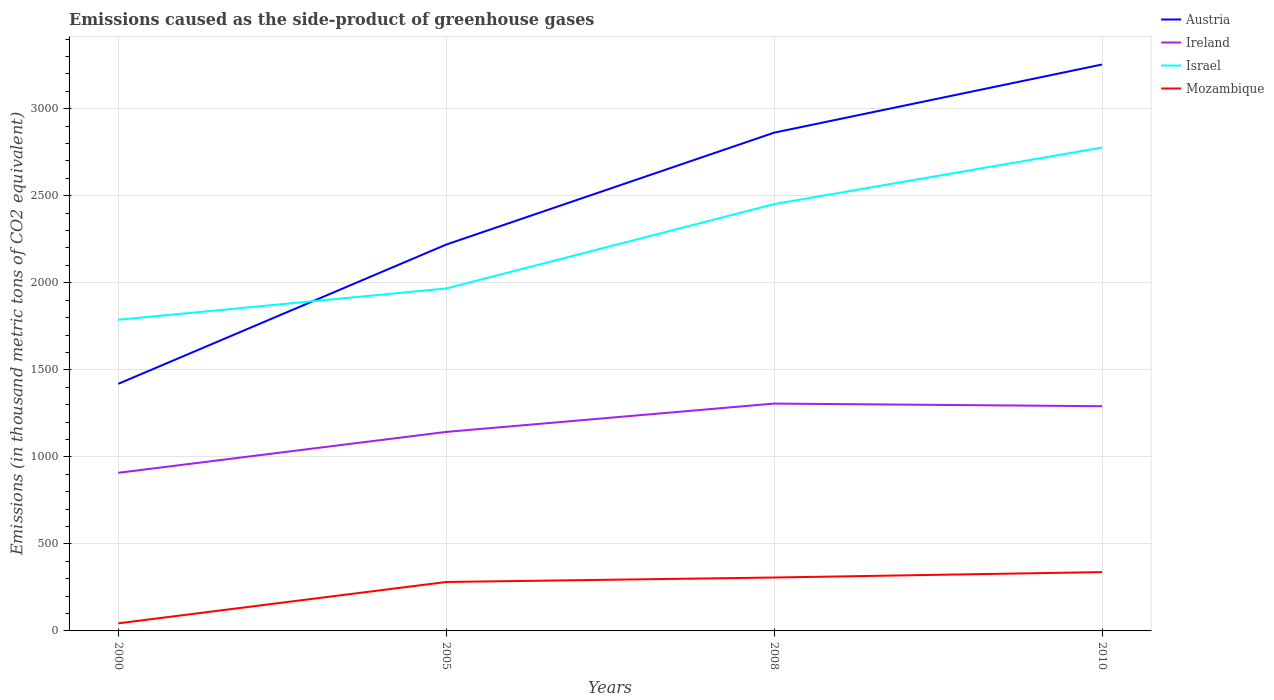How many different coloured lines are there?
Provide a short and direct response. 4. Is the number of lines equal to the number of legend labels?
Your answer should be very brief. Yes. Across all years, what is the maximum emissions caused as the side-product of greenhouse gases in Israel?
Provide a short and direct response. 1787.6. What is the total emissions caused as the side-product of greenhouse gases in Israel in the graph?
Your answer should be compact. -664.5. What is the difference between the highest and the second highest emissions caused as the side-product of greenhouse gases in Mozambique?
Your response must be concise. 294.3. What is the difference between the highest and the lowest emissions caused as the side-product of greenhouse gases in Israel?
Your response must be concise. 2. How many years are there in the graph?
Make the answer very short. 4. Are the values on the major ticks of Y-axis written in scientific E-notation?
Your answer should be compact. No. Does the graph contain grids?
Ensure brevity in your answer.  Yes. What is the title of the graph?
Your answer should be compact. Emissions caused as the side-product of greenhouse gases. What is the label or title of the Y-axis?
Provide a succinct answer. Emissions (in thousand metric tons of CO2 equivalent). What is the Emissions (in thousand metric tons of CO2 equivalent) in Austria in 2000?
Your answer should be very brief. 1419.5. What is the Emissions (in thousand metric tons of CO2 equivalent) in Ireland in 2000?
Ensure brevity in your answer.  908.4. What is the Emissions (in thousand metric tons of CO2 equivalent) in Israel in 2000?
Offer a terse response. 1787.6. What is the Emissions (in thousand metric tons of CO2 equivalent) of Mozambique in 2000?
Give a very brief answer. 43.7. What is the Emissions (in thousand metric tons of CO2 equivalent) of Austria in 2005?
Make the answer very short. 2219.5. What is the Emissions (in thousand metric tons of CO2 equivalent) in Ireland in 2005?
Ensure brevity in your answer.  1143.3. What is the Emissions (in thousand metric tons of CO2 equivalent) of Israel in 2005?
Your answer should be very brief. 1967.4. What is the Emissions (in thousand metric tons of CO2 equivalent) of Mozambique in 2005?
Your response must be concise. 281.1. What is the Emissions (in thousand metric tons of CO2 equivalent) of Austria in 2008?
Provide a succinct answer. 2862.4. What is the Emissions (in thousand metric tons of CO2 equivalent) in Ireland in 2008?
Keep it short and to the point. 1306.1. What is the Emissions (in thousand metric tons of CO2 equivalent) of Israel in 2008?
Your answer should be very brief. 2452.1. What is the Emissions (in thousand metric tons of CO2 equivalent) of Mozambique in 2008?
Offer a terse response. 306.8. What is the Emissions (in thousand metric tons of CO2 equivalent) of Austria in 2010?
Provide a short and direct response. 3254. What is the Emissions (in thousand metric tons of CO2 equivalent) of Ireland in 2010?
Make the answer very short. 1291. What is the Emissions (in thousand metric tons of CO2 equivalent) in Israel in 2010?
Your answer should be compact. 2777. What is the Emissions (in thousand metric tons of CO2 equivalent) in Mozambique in 2010?
Offer a terse response. 338. Across all years, what is the maximum Emissions (in thousand metric tons of CO2 equivalent) of Austria?
Give a very brief answer. 3254. Across all years, what is the maximum Emissions (in thousand metric tons of CO2 equivalent) of Ireland?
Offer a very short reply. 1306.1. Across all years, what is the maximum Emissions (in thousand metric tons of CO2 equivalent) of Israel?
Ensure brevity in your answer.  2777. Across all years, what is the maximum Emissions (in thousand metric tons of CO2 equivalent) of Mozambique?
Keep it short and to the point. 338. Across all years, what is the minimum Emissions (in thousand metric tons of CO2 equivalent) in Austria?
Your response must be concise. 1419.5. Across all years, what is the minimum Emissions (in thousand metric tons of CO2 equivalent) in Ireland?
Offer a very short reply. 908.4. Across all years, what is the minimum Emissions (in thousand metric tons of CO2 equivalent) in Israel?
Offer a terse response. 1787.6. Across all years, what is the minimum Emissions (in thousand metric tons of CO2 equivalent) in Mozambique?
Give a very brief answer. 43.7. What is the total Emissions (in thousand metric tons of CO2 equivalent) of Austria in the graph?
Make the answer very short. 9755.4. What is the total Emissions (in thousand metric tons of CO2 equivalent) in Ireland in the graph?
Give a very brief answer. 4648.8. What is the total Emissions (in thousand metric tons of CO2 equivalent) of Israel in the graph?
Give a very brief answer. 8984.1. What is the total Emissions (in thousand metric tons of CO2 equivalent) of Mozambique in the graph?
Provide a short and direct response. 969.6. What is the difference between the Emissions (in thousand metric tons of CO2 equivalent) in Austria in 2000 and that in 2005?
Provide a short and direct response. -800. What is the difference between the Emissions (in thousand metric tons of CO2 equivalent) in Ireland in 2000 and that in 2005?
Offer a terse response. -234.9. What is the difference between the Emissions (in thousand metric tons of CO2 equivalent) in Israel in 2000 and that in 2005?
Keep it short and to the point. -179.8. What is the difference between the Emissions (in thousand metric tons of CO2 equivalent) of Mozambique in 2000 and that in 2005?
Provide a succinct answer. -237.4. What is the difference between the Emissions (in thousand metric tons of CO2 equivalent) of Austria in 2000 and that in 2008?
Offer a very short reply. -1442.9. What is the difference between the Emissions (in thousand metric tons of CO2 equivalent) in Ireland in 2000 and that in 2008?
Make the answer very short. -397.7. What is the difference between the Emissions (in thousand metric tons of CO2 equivalent) of Israel in 2000 and that in 2008?
Ensure brevity in your answer.  -664.5. What is the difference between the Emissions (in thousand metric tons of CO2 equivalent) in Mozambique in 2000 and that in 2008?
Your response must be concise. -263.1. What is the difference between the Emissions (in thousand metric tons of CO2 equivalent) in Austria in 2000 and that in 2010?
Provide a short and direct response. -1834.5. What is the difference between the Emissions (in thousand metric tons of CO2 equivalent) of Ireland in 2000 and that in 2010?
Your response must be concise. -382.6. What is the difference between the Emissions (in thousand metric tons of CO2 equivalent) in Israel in 2000 and that in 2010?
Offer a very short reply. -989.4. What is the difference between the Emissions (in thousand metric tons of CO2 equivalent) in Mozambique in 2000 and that in 2010?
Give a very brief answer. -294.3. What is the difference between the Emissions (in thousand metric tons of CO2 equivalent) in Austria in 2005 and that in 2008?
Your response must be concise. -642.9. What is the difference between the Emissions (in thousand metric tons of CO2 equivalent) of Ireland in 2005 and that in 2008?
Make the answer very short. -162.8. What is the difference between the Emissions (in thousand metric tons of CO2 equivalent) in Israel in 2005 and that in 2008?
Provide a succinct answer. -484.7. What is the difference between the Emissions (in thousand metric tons of CO2 equivalent) of Mozambique in 2005 and that in 2008?
Make the answer very short. -25.7. What is the difference between the Emissions (in thousand metric tons of CO2 equivalent) of Austria in 2005 and that in 2010?
Give a very brief answer. -1034.5. What is the difference between the Emissions (in thousand metric tons of CO2 equivalent) of Ireland in 2005 and that in 2010?
Make the answer very short. -147.7. What is the difference between the Emissions (in thousand metric tons of CO2 equivalent) in Israel in 2005 and that in 2010?
Your answer should be very brief. -809.6. What is the difference between the Emissions (in thousand metric tons of CO2 equivalent) of Mozambique in 2005 and that in 2010?
Your response must be concise. -56.9. What is the difference between the Emissions (in thousand metric tons of CO2 equivalent) of Austria in 2008 and that in 2010?
Provide a succinct answer. -391.6. What is the difference between the Emissions (in thousand metric tons of CO2 equivalent) of Ireland in 2008 and that in 2010?
Your response must be concise. 15.1. What is the difference between the Emissions (in thousand metric tons of CO2 equivalent) in Israel in 2008 and that in 2010?
Ensure brevity in your answer.  -324.9. What is the difference between the Emissions (in thousand metric tons of CO2 equivalent) in Mozambique in 2008 and that in 2010?
Offer a terse response. -31.2. What is the difference between the Emissions (in thousand metric tons of CO2 equivalent) of Austria in 2000 and the Emissions (in thousand metric tons of CO2 equivalent) of Ireland in 2005?
Offer a very short reply. 276.2. What is the difference between the Emissions (in thousand metric tons of CO2 equivalent) in Austria in 2000 and the Emissions (in thousand metric tons of CO2 equivalent) in Israel in 2005?
Provide a succinct answer. -547.9. What is the difference between the Emissions (in thousand metric tons of CO2 equivalent) of Austria in 2000 and the Emissions (in thousand metric tons of CO2 equivalent) of Mozambique in 2005?
Offer a very short reply. 1138.4. What is the difference between the Emissions (in thousand metric tons of CO2 equivalent) in Ireland in 2000 and the Emissions (in thousand metric tons of CO2 equivalent) in Israel in 2005?
Give a very brief answer. -1059. What is the difference between the Emissions (in thousand metric tons of CO2 equivalent) in Ireland in 2000 and the Emissions (in thousand metric tons of CO2 equivalent) in Mozambique in 2005?
Your answer should be compact. 627.3. What is the difference between the Emissions (in thousand metric tons of CO2 equivalent) in Israel in 2000 and the Emissions (in thousand metric tons of CO2 equivalent) in Mozambique in 2005?
Keep it short and to the point. 1506.5. What is the difference between the Emissions (in thousand metric tons of CO2 equivalent) of Austria in 2000 and the Emissions (in thousand metric tons of CO2 equivalent) of Ireland in 2008?
Offer a very short reply. 113.4. What is the difference between the Emissions (in thousand metric tons of CO2 equivalent) of Austria in 2000 and the Emissions (in thousand metric tons of CO2 equivalent) of Israel in 2008?
Your answer should be compact. -1032.6. What is the difference between the Emissions (in thousand metric tons of CO2 equivalent) of Austria in 2000 and the Emissions (in thousand metric tons of CO2 equivalent) of Mozambique in 2008?
Ensure brevity in your answer.  1112.7. What is the difference between the Emissions (in thousand metric tons of CO2 equivalent) in Ireland in 2000 and the Emissions (in thousand metric tons of CO2 equivalent) in Israel in 2008?
Provide a short and direct response. -1543.7. What is the difference between the Emissions (in thousand metric tons of CO2 equivalent) of Ireland in 2000 and the Emissions (in thousand metric tons of CO2 equivalent) of Mozambique in 2008?
Provide a short and direct response. 601.6. What is the difference between the Emissions (in thousand metric tons of CO2 equivalent) in Israel in 2000 and the Emissions (in thousand metric tons of CO2 equivalent) in Mozambique in 2008?
Offer a very short reply. 1480.8. What is the difference between the Emissions (in thousand metric tons of CO2 equivalent) of Austria in 2000 and the Emissions (in thousand metric tons of CO2 equivalent) of Ireland in 2010?
Make the answer very short. 128.5. What is the difference between the Emissions (in thousand metric tons of CO2 equivalent) of Austria in 2000 and the Emissions (in thousand metric tons of CO2 equivalent) of Israel in 2010?
Your answer should be very brief. -1357.5. What is the difference between the Emissions (in thousand metric tons of CO2 equivalent) of Austria in 2000 and the Emissions (in thousand metric tons of CO2 equivalent) of Mozambique in 2010?
Your answer should be compact. 1081.5. What is the difference between the Emissions (in thousand metric tons of CO2 equivalent) of Ireland in 2000 and the Emissions (in thousand metric tons of CO2 equivalent) of Israel in 2010?
Provide a succinct answer. -1868.6. What is the difference between the Emissions (in thousand metric tons of CO2 equivalent) in Ireland in 2000 and the Emissions (in thousand metric tons of CO2 equivalent) in Mozambique in 2010?
Offer a terse response. 570.4. What is the difference between the Emissions (in thousand metric tons of CO2 equivalent) in Israel in 2000 and the Emissions (in thousand metric tons of CO2 equivalent) in Mozambique in 2010?
Offer a very short reply. 1449.6. What is the difference between the Emissions (in thousand metric tons of CO2 equivalent) of Austria in 2005 and the Emissions (in thousand metric tons of CO2 equivalent) of Ireland in 2008?
Provide a short and direct response. 913.4. What is the difference between the Emissions (in thousand metric tons of CO2 equivalent) of Austria in 2005 and the Emissions (in thousand metric tons of CO2 equivalent) of Israel in 2008?
Provide a succinct answer. -232.6. What is the difference between the Emissions (in thousand metric tons of CO2 equivalent) in Austria in 2005 and the Emissions (in thousand metric tons of CO2 equivalent) in Mozambique in 2008?
Your answer should be very brief. 1912.7. What is the difference between the Emissions (in thousand metric tons of CO2 equivalent) in Ireland in 2005 and the Emissions (in thousand metric tons of CO2 equivalent) in Israel in 2008?
Provide a short and direct response. -1308.8. What is the difference between the Emissions (in thousand metric tons of CO2 equivalent) in Ireland in 2005 and the Emissions (in thousand metric tons of CO2 equivalent) in Mozambique in 2008?
Make the answer very short. 836.5. What is the difference between the Emissions (in thousand metric tons of CO2 equivalent) of Israel in 2005 and the Emissions (in thousand metric tons of CO2 equivalent) of Mozambique in 2008?
Offer a very short reply. 1660.6. What is the difference between the Emissions (in thousand metric tons of CO2 equivalent) of Austria in 2005 and the Emissions (in thousand metric tons of CO2 equivalent) of Ireland in 2010?
Offer a terse response. 928.5. What is the difference between the Emissions (in thousand metric tons of CO2 equivalent) in Austria in 2005 and the Emissions (in thousand metric tons of CO2 equivalent) in Israel in 2010?
Give a very brief answer. -557.5. What is the difference between the Emissions (in thousand metric tons of CO2 equivalent) of Austria in 2005 and the Emissions (in thousand metric tons of CO2 equivalent) of Mozambique in 2010?
Give a very brief answer. 1881.5. What is the difference between the Emissions (in thousand metric tons of CO2 equivalent) of Ireland in 2005 and the Emissions (in thousand metric tons of CO2 equivalent) of Israel in 2010?
Your response must be concise. -1633.7. What is the difference between the Emissions (in thousand metric tons of CO2 equivalent) in Ireland in 2005 and the Emissions (in thousand metric tons of CO2 equivalent) in Mozambique in 2010?
Your answer should be compact. 805.3. What is the difference between the Emissions (in thousand metric tons of CO2 equivalent) in Israel in 2005 and the Emissions (in thousand metric tons of CO2 equivalent) in Mozambique in 2010?
Provide a succinct answer. 1629.4. What is the difference between the Emissions (in thousand metric tons of CO2 equivalent) of Austria in 2008 and the Emissions (in thousand metric tons of CO2 equivalent) of Ireland in 2010?
Make the answer very short. 1571.4. What is the difference between the Emissions (in thousand metric tons of CO2 equivalent) in Austria in 2008 and the Emissions (in thousand metric tons of CO2 equivalent) in Israel in 2010?
Your response must be concise. 85.4. What is the difference between the Emissions (in thousand metric tons of CO2 equivalent) of Austria in 2008 and the Emissions (in thousand metric tons of CO2 equivalent) of Mozambique in 2010?
Provide a short and direct response. 2524.4. What is the difference between the Emissions (in thousand metric tons of CO2 equivalent) of Ireland in 2008 and the Emissions (in thousand metric tons of CO2 equivalent) of Israel in 2010?
Provide a succinct answer. -1470.9. What is the difference between the Emissions (in thousand metric tons of CO2 equivalent) of Ireland in 2008 and the Emissions (in thousand metric tons of CO2 equivalent) of Mozambique in 2010?
Keep it short and to the point. 968.1. What is the difference between the Emissions (in thousand metric tons of CO2 equivalent) of Israel in 2008 and the Emissions (in thousand metric tons of CO2 equivalent) of Mozambique in 2010?
Ensure brevity in your answer.  2114.1. What is the average Emissions (in thousand metric tons of CO2 equivalent) of Austria per year?
Your answer should be very brief. 2438.85. What is the average Emissions (in thousand metric tons of CO2 equivalent) of Ireland per year?
Provide a succinct answer. 1162.2. What is the average Emissions (in thousand metric tons of CO2 equivalent) of Israel per year?
Ensure brevity in your answer.  2246.03. What is the average Emissions (in thousand metric tons of CO2 equivalent) of Mozambique per year?
Offer a terse response. 242.4. In the year 2000, what is the difference between the Emissions (in thousand metric tons of CO2 equivalent) of Austria and Emissions (in thousand metric tons of CO2 equivalent) of Ireland?
Your response must be concise. 511.1. In the year 2000, what is the difference between the Emissions (in thousand metric tons of CO2 equivalent) of Austria and Emissions (in thousand metric tons of CO2 equivalent) of Israel?
Provide a succinct answer. -368.1. In the year 2000, what is the difference between the Emissions (in thousand metric tons of CO2 equivalent) in Austria and Emissions (in thousand metric tons of CO2 equivalent) in Mozambique?
Keep it short and to the point. 1375.8. In the year 2000, what is the difference between the Emissions (in thousand metric tons of CO2 equivalent) of Ireland and Emissions (in thousand metric tons of CO2 equivalent) of Israel?
Your answer should be very brief. -879.2. In the year 2000, what is the difference between the Emissions (in thousand metric tons of CO2 equivalent) of Ireland and Emissions (in thousand metric tons of CO2 equivalent) of Mozambique?
Ensure brevity in your answer.  864.7. In the year 2000, what is the difference between the Emissions (in thousand metric tons of CO2 equivalent) of Israel and Emissions (in thousand metric tons of CO2 equivalent) of Mozambique?
Your answer should be compact. 1743.9. In the year 2005, what is the difference between the Emissions (in thousand metric tons of CO2 equivalent) of Austria and Emissions (in thousand metric tons of CO2 equivalent) of Ireland?
Make the answer very short. 1076.2. In the year 2005, what is the difference between the Emissions (in thousand metric tons of CO2 equivalent) in Austria and Emissions (in thousand metric tons of CO2 equivalent) in Israel?
Provide a succinct answer. 252.1. In the year 2005, what is the difference between the Emissions (in thousand metric tons of CO2 equivalent) of Austria and Emissions (in thousand metric tons of CO2 equivalent) of Mozambique?
Your answer should be compact. 1938.4. In the year 2005, what is the difference between the Emissions (in thousand metric tons of CO2 equivalent) in Ireland and Emissions (in thousand metric tons of CO2 equivalent) in Israel?
Keep it short and to the point. -824.1. In the year 2005, what is the difference between the Emissions (in thousand metric tons of CO2 equivalent) in Ireland and Emissions (in thousand metric tons of CO2 equivalent) in Mozambique?
Offer a terse response. 862.2. In the year 2005, what is the difference between the Emissions (in thousand metric tons of CO2 equivalent) in Israel and Emissions (in thousand metric tons of CO2 equivalent) in Mozambique?
Your answer should be compact. 1686.3. In the year 2008, what is the difference between the Emissions (in thousand metric tons of CO2 equivalent) of Austria and Emissions (in thousand metric tons of CO2 equivalent) of Ireland?
Make the answer very short. 1556.3. In the year 2008, what is the difference between the Emissions (in thousand metric tons of CO2 equivalent) in Austria and Emissions (in thousand metric tons of CO2 equivalent) in Israel?
Ensure brevity in your answer.  410.3. In the year 2008, what is the difference between the Emissions (in thousand metric tons of CO2 equivalent) of Austria and Emissions (in thousand metric tons of CO2 equivalent) of Mozambique?
Ensure brevity in your answer.  2555.6. In the year 2008, what is the difference between the Emissions (in thousand metric tons of CO2 equivalent) of Ireland and Emissions (in thousand metric tons of CO2 equivalent) of Israel?
Keep it short and to the point. -1146. In the year 2008, what is the difference between the Emissions (in thousand metric tons of CO2 equivalent) in Ireland and Emissions (in thousand metric tons of CO2 equivalent) in Mozambique?
Make the answer very short. 999.3. In the year 2008, what is the difference between the Emissions (in thousand metric tons of CO2 equivalent) in Israel and Emissions (in thousand metric tons of CO2 equivalent) in Mozambique?
Offer a very short reply. 2145.3. In the year 2010, what is the difference between the Emissions (in thousand metric tons of CO2 equivalent) in Austria and Emissions (in thousand metric tons of CO2 equivalent) in Ireland?
Offer a terse response. 1963. In the year 2010, what is the difference between the Emissions (in thousand metric tons of CO2 equivalent) of Austria and Emissions (in thousand metric tons of CO2 equivalent) of Israel?
Give a very brief answer. 477. In the year 2010, what is the difference between the Emissions (in thousand metric tons of CO2 equivalent) of Austria and Emissions (in thousand metric tons of CO2 equivalent) of Mozambique?
Your answer should be compact. 2916. In the year 2010, what is the difference between the Emissions (in thousand metric tons of CO2 equivalent) in Ireland and Emissions (in thousand metric tons of CO2 equivalent) in Israel?
Keep it short and to the point. -1486. In the year 2010, what is the difference between the Emissions (in thousand metric tons of CO2 equivalent) of Ireland and Emissions (in thousand metric tons of CO2 equivalent) of Mozambique?
Offer a very short reply. 953. In the year 2010, what is the difference between the Emissions (in thousand metric tons of CO2 equivalent) of Israel and Emissions (in thousand metric tons of CO2 equivalent) of Mozambique?
Your answer should be compact. 2439. What is the ratio of the Emissions (in thousand metric tons of CO2 equivalent) of Austria in 2000 to that in 2005?
Offer a terse response. 0.64. What is the ratio of the Emissions (in thousand metric tons of CO2 equivalent) of Ireland in 2000 to that in 2005?
Your answer should be very brief. 0.79. What is the ratio of the Emissions (in thousand metric tons of CO2 equivalent) of Israel in 2000 to that in 2005?
Provide a succinct answer. 0.91. What is the ratio of the Emissions (in thousand metric tons of CO2 equivalent) of Mozambique in 2000 to that in 2005?
Make the answer very short. 0.16. What is the ratio of the Emissions (in thousand metric tons of CO2 equivalent) of Austria in 2000 to that in 2008?
Offer a terse response. 0.5. What is the ratio of the Emissions (in thousand metric tons of CO2 equivalent) of Ireland in 2000 to that in 2008?
Provide a short and direct response. 0.7. What is the ratio of the Emissions (in thousand metric tons of CO2 equivalent) of Israel in 2000 to that in 2008?
Your answer should be very brief. 0.73. What is the ratio of the Emissions (in thousand metric tons of CO2 equivalent) of Mozambique in 2000 to that in 2008?
Make the answer very short. 0.14. What is the ratio of the Emissions (in thousand metric tons of CO2 equivalent) in Austria in 2000 to that in 2010?
Keep it short and to the point. 0.44. What is the ratio of the Emissions (in thousand metric tons of CO2 equivalent) in Ireland in 2000 to that in 2010?
Make the answer very short. 0.7. What is the ratio of the Emissions (in thousand metric tons of CO2 equivalent) of Israel in 2000 to that in 2010?
Your answer should be compact. 0.64. What is the ratio of the Emissions (in thousand metric tons of CO2 equivalent) of Mozambique in 2000 to that in 2010?
Provide a short and direct response. 0.13. What is the ratio of the Emissions (in thousand metric tons of CO2 equivalent) of Austria in 2005 to that in 2008?
Offer a very short reply. 0.78. What is the ratio of the Emissions (in thousand metric tons of CO2 equivalent) in Ireland in 2005 to that in 2008?
Provide a short and direct response. 0.88. What is the ratio of the Emissions (in thousand metric tons of CO2 equivalent) of Israel in 2005 to that in 2008?
Your response must be concise. 0.8. What is the ratio of the Emissions (in thousand metric tons of CO2 equivalent) in Mozambique in 2005 to that in 2008?
Provide a short and direct response. 0.92. What is the ratio of the Emissions (in thousand metric tons of CO2 equivalent) of Austria in 2005 to that in 2010?
Provide a succinct answer. 0.68. What is the ratio of the Emissions (in thousand metric tons of CO2 equivalent) in Ireland in 2005 to that in 2010?
Provide a succinct answer. 0.89. What is the ratio of the Emissions (in thousand metric tons of CO2 equivalent) in Israel in 2005 to that in 2010?
Offer a very short reply. 0.71. What is the ratio of the Emissions (in thousand metric tons of CO2 equivalent) of Mozambique in 2005 to that in 2010?
Keep it short and to the point. 0.83. What is the ratio of the Emissions (in thousand metric tons of CO2 equivalent) of Austria in 2008 to that in 2010?
Ensure brevity in your answer.  0.88. What is the ratio of the Emissions (in thousand metric tons of CO2 equivalent) of Ireland in 2008 to that in 2010?
Make the answer very short. 1.01. What is the ratio of the Emissions (in thousand metric tons of CO2 equivalent) of Israel in 2008 to that in 2010?
Provide a succinct answer. 0.88. What is the ratio of the Emissions (in thousand metric tons of CO2 equivalent) in Mozambique in 2008 to that in 2010?
Your answer should be very brief. 0.91. What is the difference between the highest and the second highest Emissions (in thousand metric tons of CO2 equivalent) of Austria?
Provide a short and direct response. 391.6. What is the difference between the highest and the second highest Emissions (in thousand metric tons of CO2 equivalent) of Israel?
Your answer should be compact. 324.9. What is the difference between the highest and the second highest Emissions (in thousand metric tons of CO2 equivalent) of Mozambique?
Your response must be concise. 31.2. What is the difference between the highest and the lowest Emissions (in thousand metric tons of CO2 equivalent) in Austria?
Your answer should be compact. 1834.5. What is the difference between the highest and the lowest Emissions (in thousand metric tons of CO2 equivalent) of Ireland?
Give a very brief answer. 397.7. What is the difference between the highest and the lowest Emissions (in thousand metric tons of CO2 equivalent) of Israel?
Provide a short and direct response. 989.4. What is the difference between the highest and the lowest Emissions (in thousand metric tons of CO2 equivalent) of Mozambique?
Make the answer very short. 294.3. 